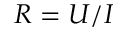Convert formula to latex. <formula><loc_0><loc_0><loc_500><loc_500>R = U / I</formula> 